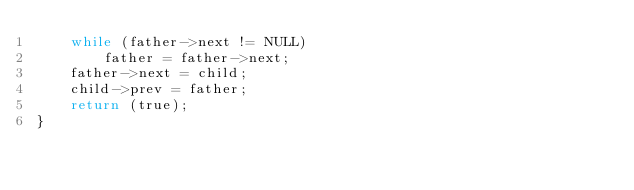Convert code to text. <code><loc_0><loc_0><loc_500><loc_500><_C_>	while (father->next != NULL)
		father = father->next;
	father->next = child;
	child->prev = father;
	return (true);
}
</code> 